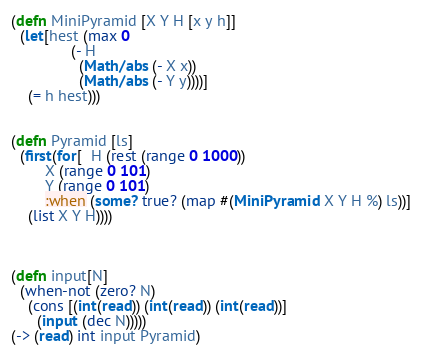Convert code to text. <code><loc_0><loc_0><loc_500><loc_500><_Clojure_>(defn MiniPyramid [X Y H [x y h]]
  (let[hest (max 0 
              (- H 
                (Math/abs (- X x)) 
                (Math/abs (- Y y))))]
    (= h hest)))
              

(defn Pyramid [ls]
  (first(for[  H (rest (range 0 1000))
        X (range 0 101) 
        Y (range 0 101)
        :when (some? true? (map #(MiniPyramid X Y H %) ls))]
    (list X Y H))))



(defn input[N]
  (when-not (zero? N)
    (cons [(int(read)) (int(read)) (int(read))]      
      (input (dec N)))))
(-> (read) int input Pyramid)</code> 